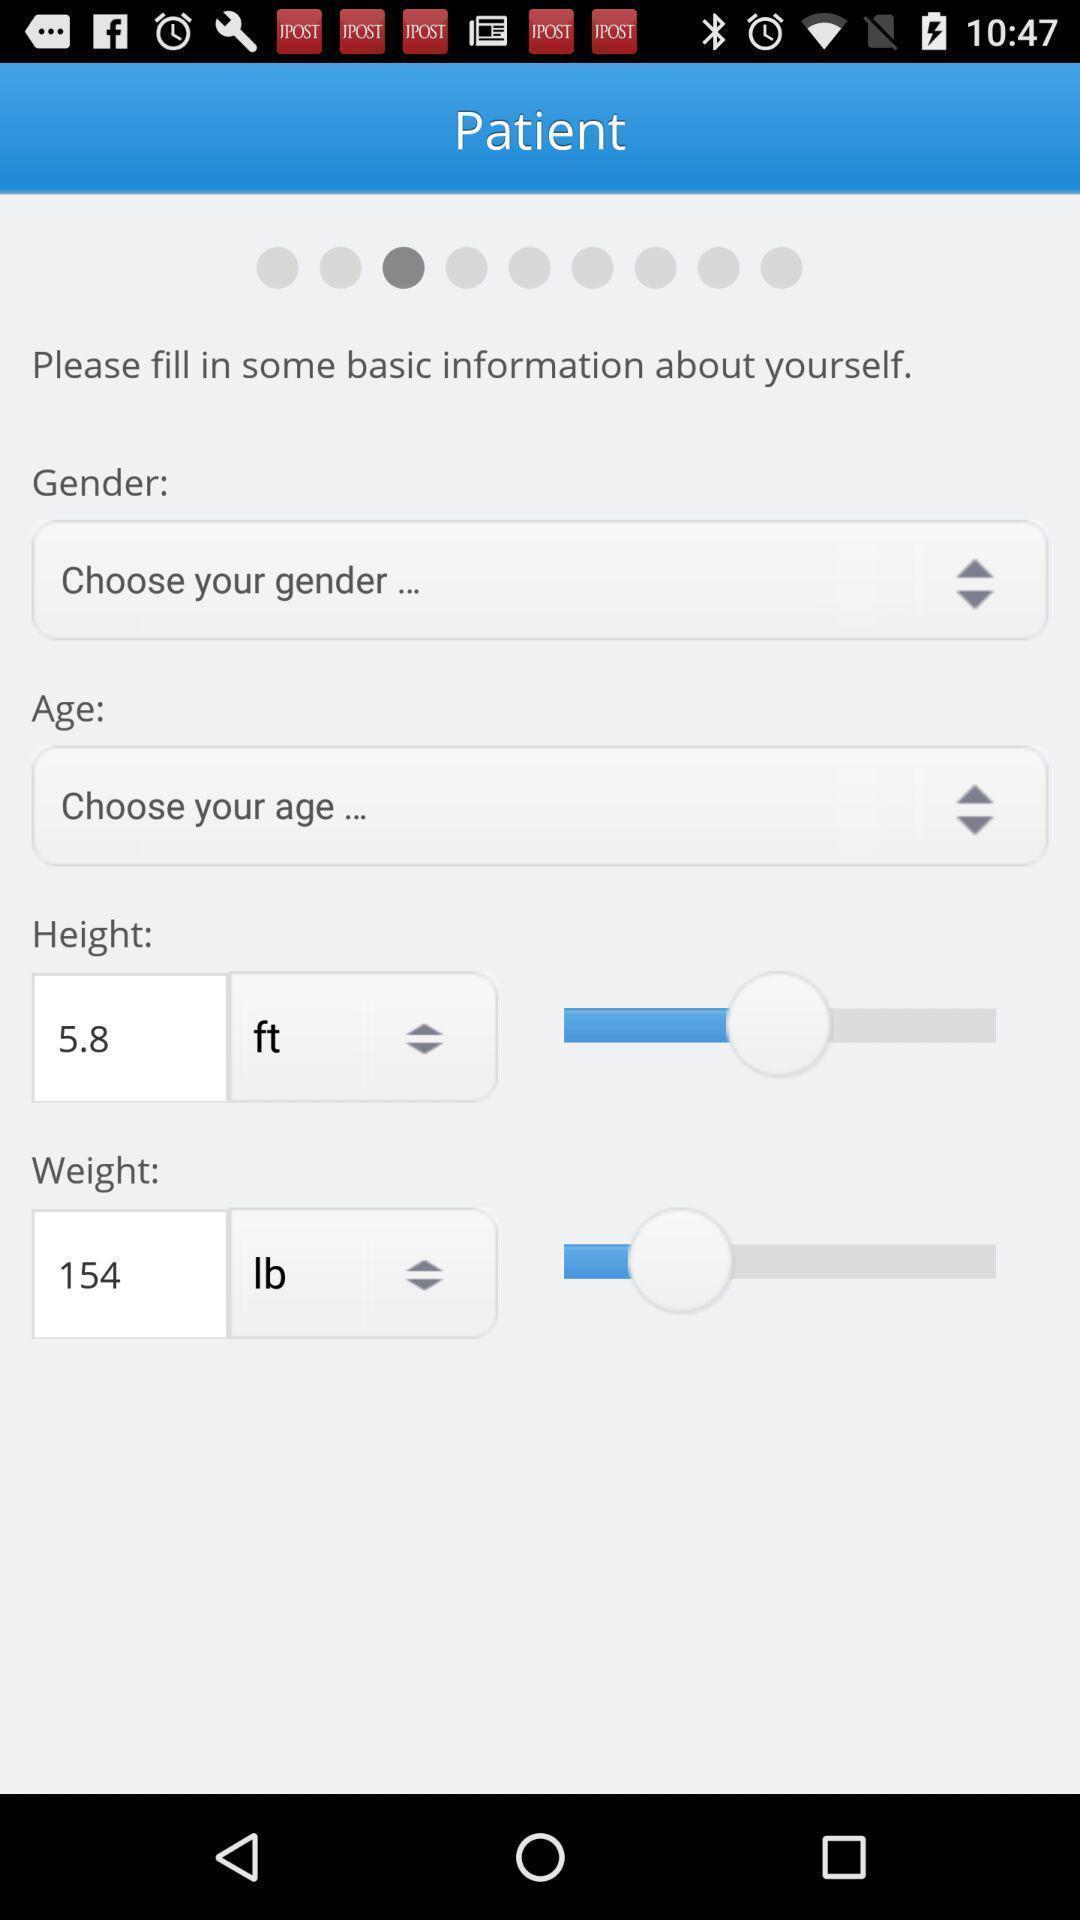What details can you identify in this image? Page to fill patient details in the doctor app. 